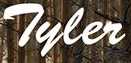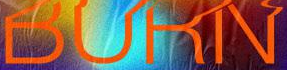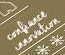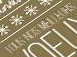What words can you see in these images in sequence, separated by a semicolon? Tyler; BURN; #; # 